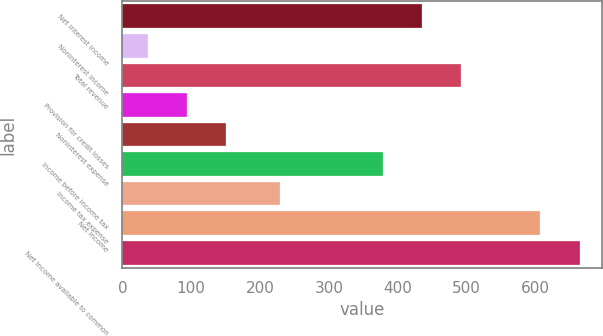<chart> <loc_0><loc_0><loc_500><loc_500><bar_chart><fcel>Net interest income<fcel>Noninterest income<fcel>Total revenue<fcel>Provision for credit losses<fcel>Noninterest expense<fcel>Income before income tax<fcel>Income tax expense<fcel>Net income<fcel>Net income available to common<nl><fcel>435<fcel>37<fcel>492<fcel>94<fcel>151<fcel>378<fcel>229<fcel>607<fcel>664<nl></chart> 